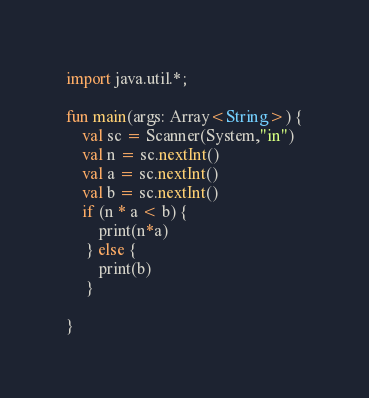<code> <loc_0><loc_0><loc_500><loc_500><_Kotlin_>import java.util.*;

fun main(args: Array<String>) {
    val sc = Scanner(System,"in")
    val n = sc.nextInt()
    val a = sc.nextInt()
    val b = sc.nextInt()
    if (n * a < b) {
        print(n*a)
     } else {
        print(b)
     }

}</code> 